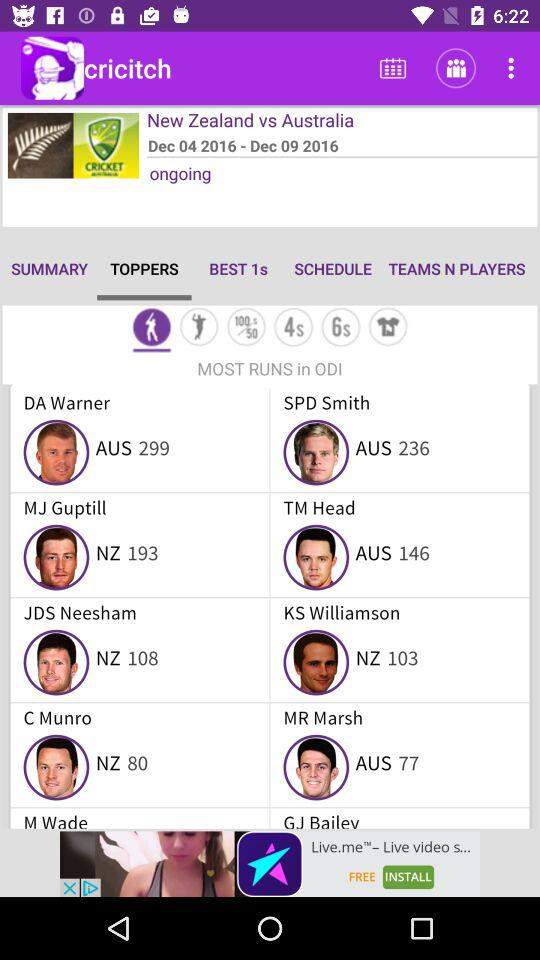Who are the top scorers? The top scorers are DA Warner, SPD Smith, MJ Guptill, TM Head, JDS Neesham, KS Williamson, C Munro, MR Marsh, M Wade and GJ Bailey. 